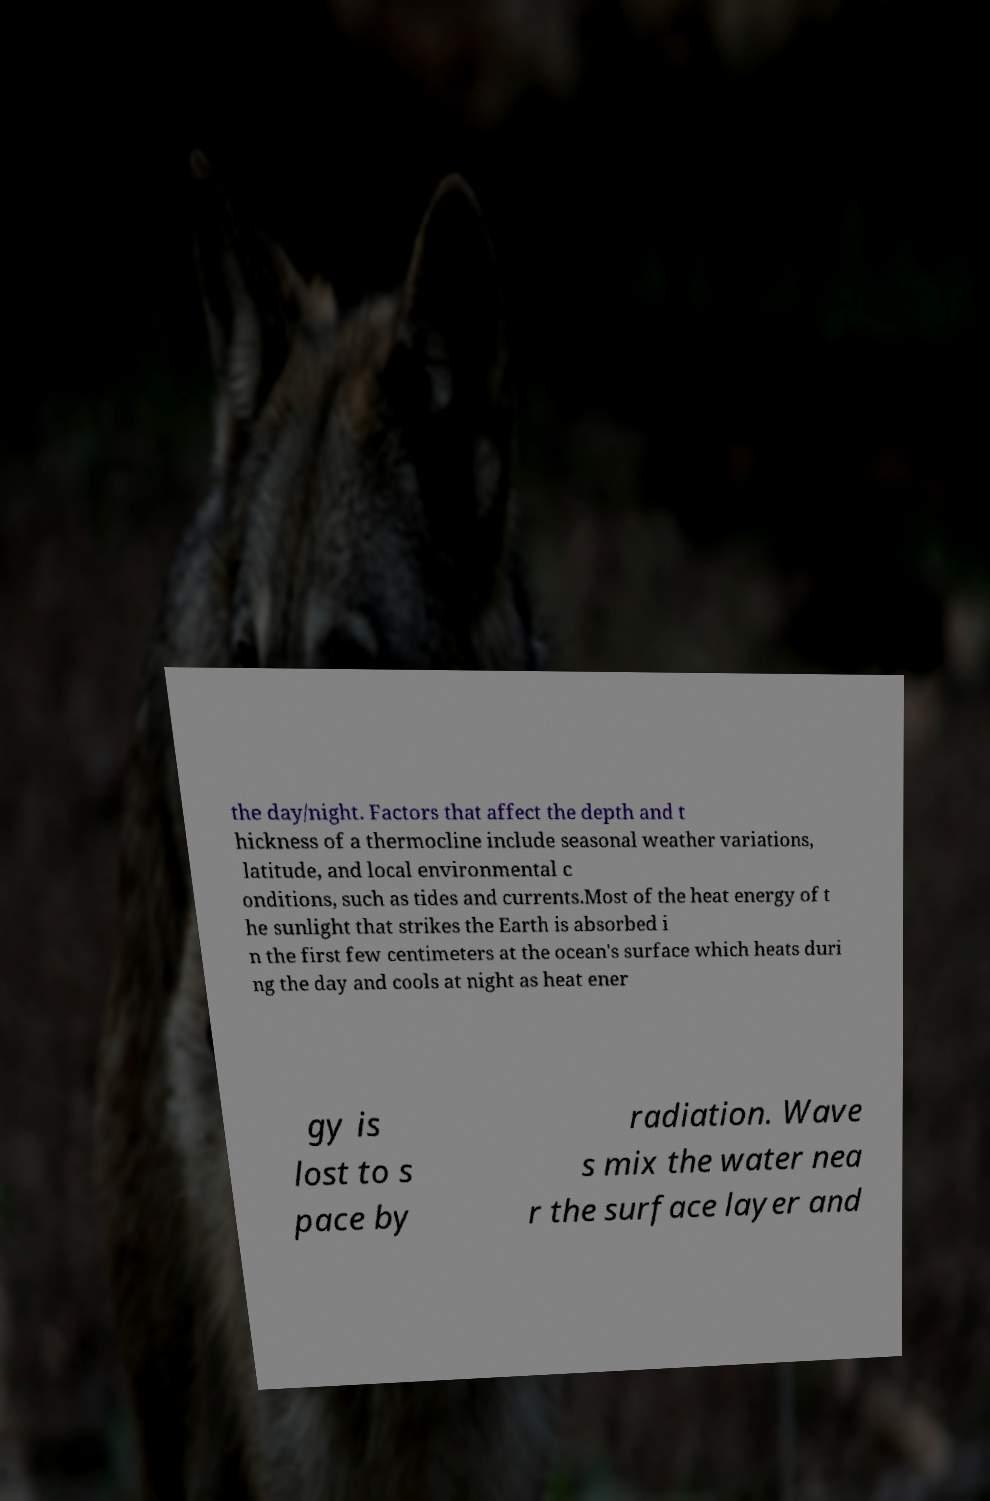I need the written content from this picture converted into text. Can you do that? the day/night. Factors that affect the depth and t hickness of a thermocline include seasonal weather variations, latitude, and local environmental c onditions, such as tides and currents.Most of the heat energy of t he sunlight that strikes the Earth is absorbed i n the first few centimeters at the ocean's surface which heats duri ng the day and cools at night as heat ener gy is lost to s pace by radiation. Wave s mix the water nea r the surface layer and 